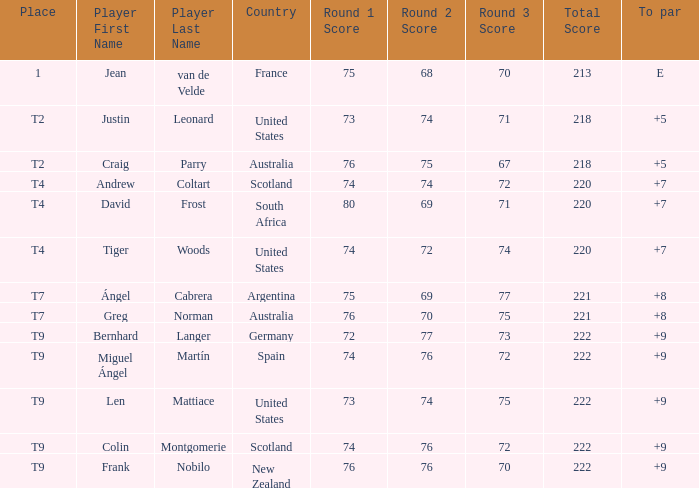Player Craig Parry of Australia is in what place number? T2. I'm looking to parse the entire table for insights. Could you assist me with that? {'header': ['Place', 'Player First Name', 'Player Last Name', 'Country', 'Round 1 Score', 'Round 2 Score', 'Round 3 Score', 'Total Score', 'To par'], 'rows': [['1', 'Jean', 'van de Velde', 'France', '75', '68', '70', '213', 'E'], ['T2', 'Justin', 'Leonard', 'United States', '73', '74', '71', '218', '+5'], ['T2', 'Craig', 'Parry', 'Australia', '76', '75', '67', '218', '+5'], ['T4', 'Andrew', 'Coltart', 'Scotland', '74', '74', '72', '220', '+7'], ['T4', 'David', 'Frost', 'South Africa', '80', '69', '71', '220', '+7'], ['T4', 'Tiger', 'Woods', 'United States', '74', '72', '74', '220', '+7'], ['T7', 'Ángel', 'Cabrera', 'Argentina', '75', '69', '77', '221', '+8'], ['T7', 'Greg', 'Norman', 'Australia', '76', '70', '75', '221', '+8'], ['T9', 'Bernhard', 'Langer', 'Germany', '72', '77', '73', '222', '+9'], ['T9', 'Miguel Ángel', 'Martín', 'Spain', '74', '76', '72', '222', '+9'], ['T9', 'Len', 'Mattiace', 'United States', '73', '74', '75', '222', '+9'], ['T9', 'Colin', 'Montgomerie', 'Scotland', '74', '76', '72', '222', '+9'], ['T9', 'Frank', 'Nobilo', 'New Zealand', '76', '76', '70', '222', '+9']]} 